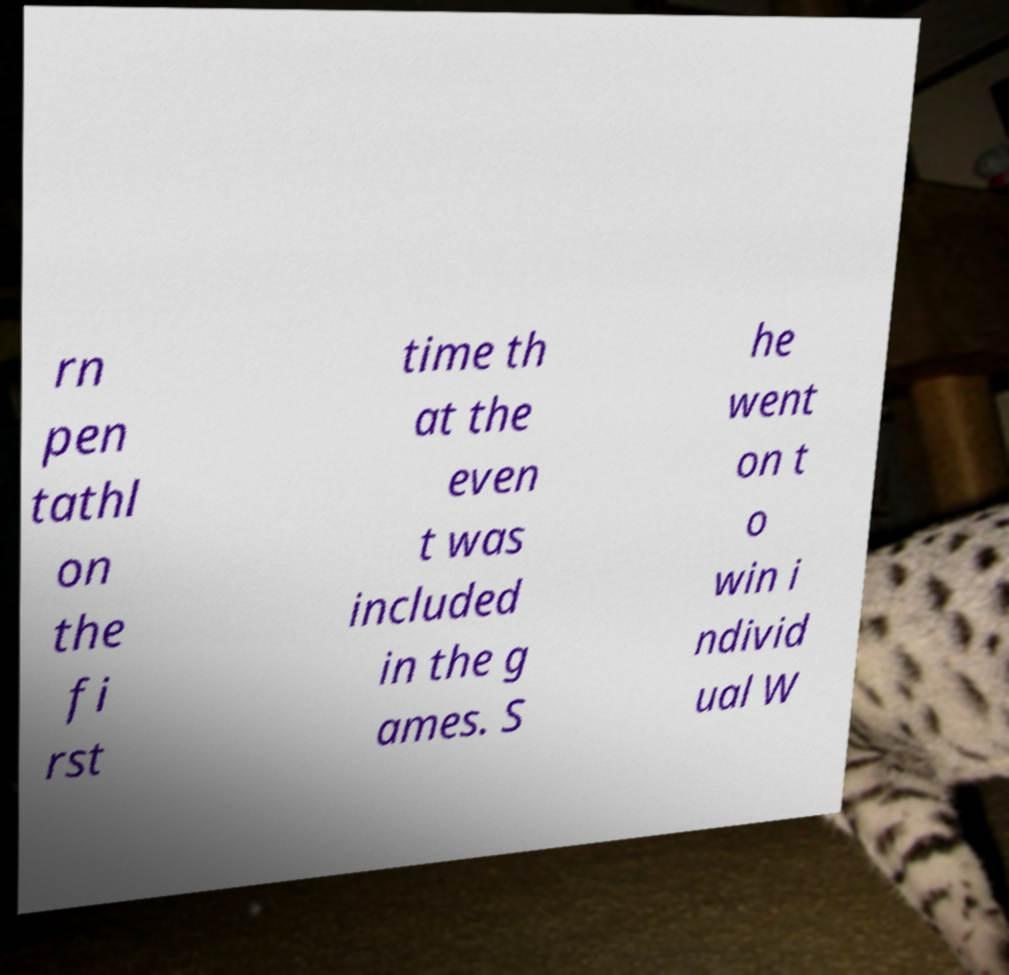There's text embedded in this image that I need extracted. Can you transcribe it verbatim? rn pen tathl on the fi rst time th at the even t was included in the g ames. S he went on t o win i ndivid ual W 